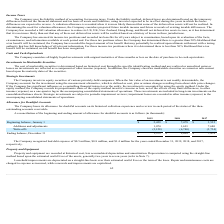According to Cornerstone Ondemand's financial document, What was the company's bad debt expense for the year ending December 31, 2018? According to the financial document, $0.8 million. The relevant text states: "mpany recognized bad debt expense of $0.5 million, $0.8 million, and $1.4 million for the years ended December 31, 2019, 2018, and 2017,..." Also, What was the beginning balance in January 1 2019? According to the financial document, $2,429 (in thousands). The relevant text states: "Beginning balance, January 1 $ 2,429 $ 7,478 $ 3,532..." Also, What was the ending balance in December 31 2017? According to the financial document, $7,478 (in thousands). The relevant text states: "Beginning balance, January 1 $ 2,429 $ 7,478 $ 3,532..." Also, can you calculate: What is the change in additions and adjustments between 2017 and 2018? Based on the calculation: (1,691-7,680), the result is -5989 (in thousands). This is based on the information: "Additions and adjustments 1,074 1,691 7,680 Additions and adjustments 1,074 1,691 7,680..." The key data points involved are: 1,691, 7,680. Also, can you calculate: What is the average year-on-year change for Additions and adjustments from 2017-2019?  To answer this question, I need to perform calculations using the financial data. The calculation is: ((1,074-1,691)/1,691+(1,691-7,680)/7,680)/2, which equals -57.23 (percentage). This is based on the information: "Additions and adjustments 1,074 1,691 7,680 Additions and adjustments 1,074 1,691 7,680 Additions and adjustments 1,074 1,691 7,680..." The key data points involved are: 1,074, 1,691, 7,680. Also, can you calculate: What is the percentage change in the ending balance between 2018 and 2019? To answer this question, I need to perform calculations using the financial data. The calculation is: ($1,375-$2,429)/$2,429, which equals -43.39 (percentage). This is based on the information: "Beginning balance, January 1 $ 2,429 $ 7,478 $ 3,532 Ending balance, December 31 $ 1,375 $ 2,429 $ 7,478..." The key data points involved are: 1,375, 2,429. 